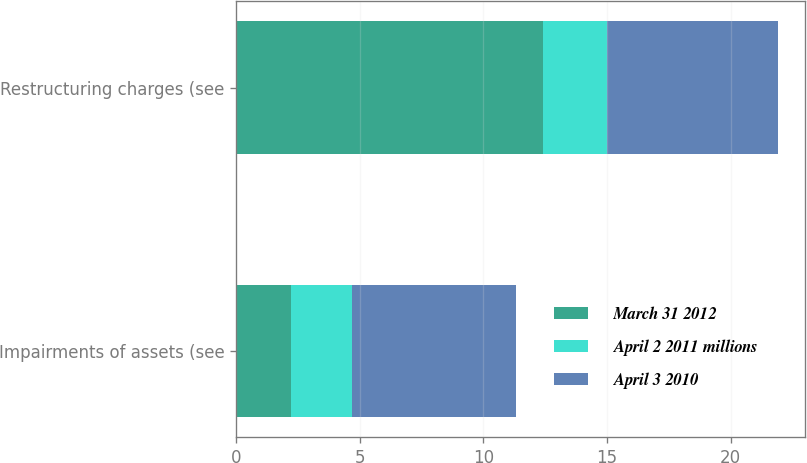<chart> <loc_0><loc_0><loc_500><loc_500><stacked_bar_chart><ecel><fcel>Impairments of assets (see<fcel>Restructuring charges (see<nl><fcel>March 31 2012<fcel>2.2<fcel>12.4<nl><fcel>April 2 2011 millions<fcel>2.5<fcel>2.6<nl><fcel>April 3 2010<fcel>6.6<fcel>6.9<nl></chart> 